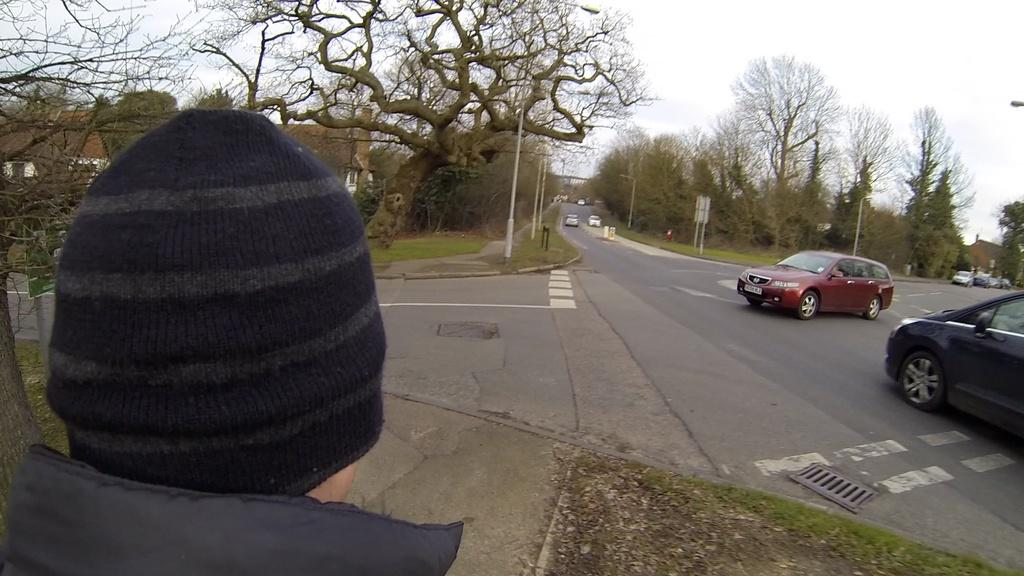What type of vehicles can be seen on the road in the image? There are cars on the road in the image. What type of vegetation is visible in the image? There is grass visible in the image, and there are also trees. What type of structures can be seen in the image? There are buildings in the image. Can you describe the person in the image? There is a person wearing a cap in the image. What is visible in the background of the image? The sky is visible in the background of the image. What type of fire can be seen in the image? There is no fire present in the image. What caption is written on the person's skirt in the image? There is no skirt present in the image, and therefore no caption can be read. 